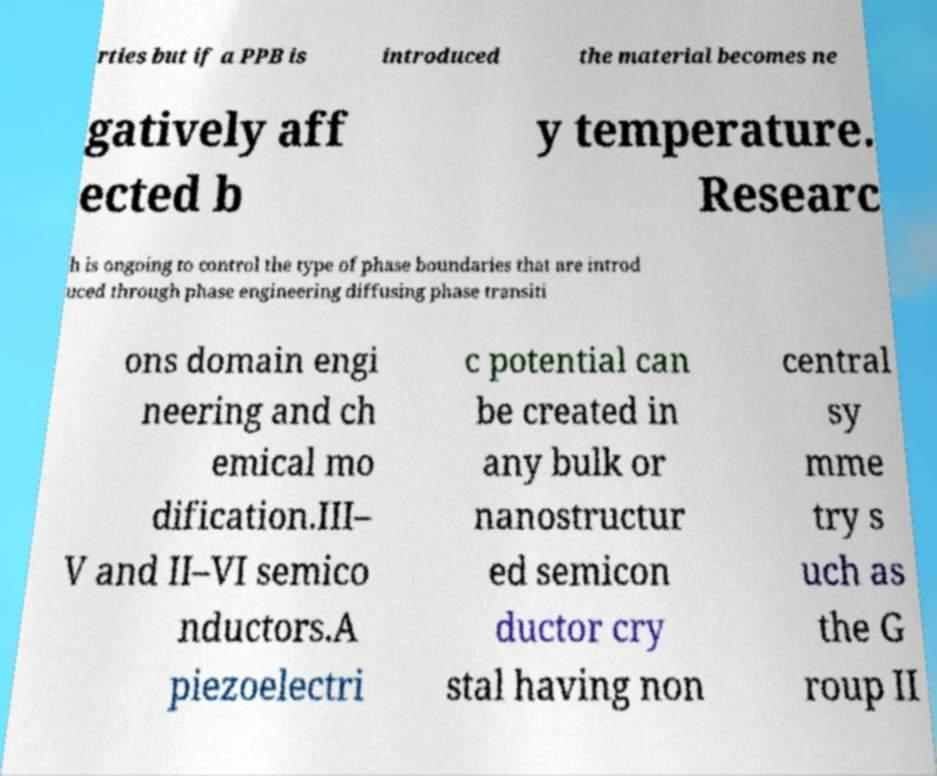Can you accurately transcribe the text from the provided image for me? rties but if a PPB is introduced the material becomes ne gatively aff ected b y temperature. Researc h is ongoing to control the type of phase boundaries that are introd uced through phase engineering diffusing phase transiti ons domain engi neering and ch emical mo dification.III– V and II–VI semico nductors.A piezoelectri c potential can be created in any bulk or nanostructur ed semicon ductor cry stal having non central sy mme try s uch as the G roup II 